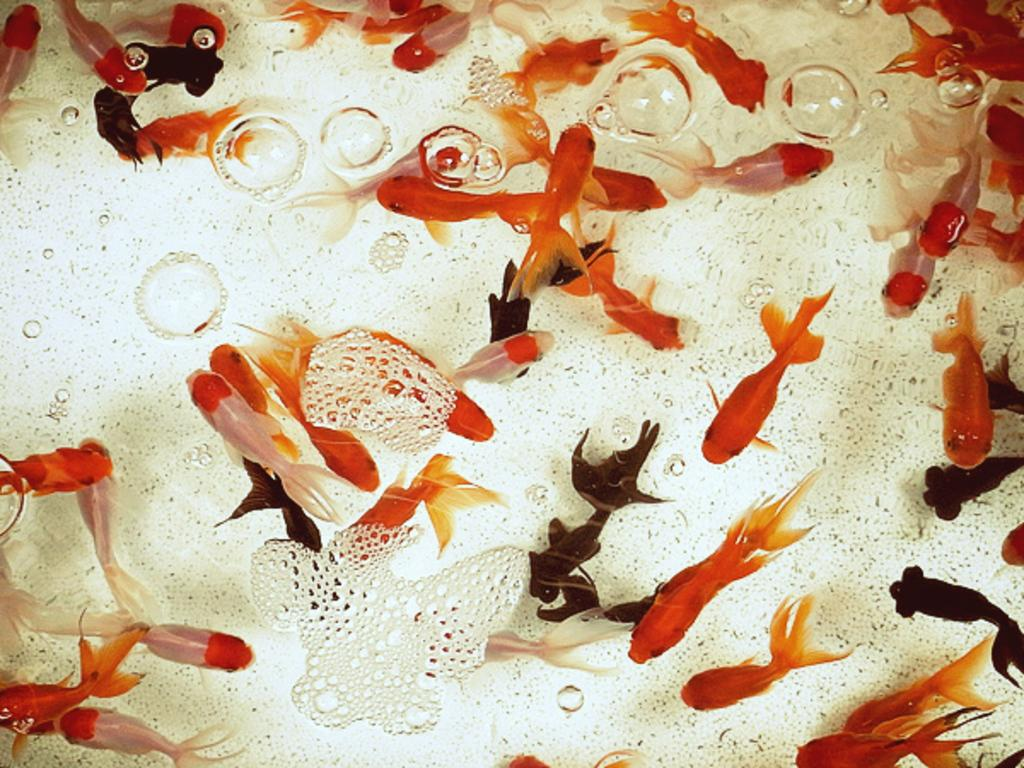What type of animals are in the image? There are fishes in the image. Where are the fishes located? The fishes are inside the water. What type of cable can be seen connecting the fishes in the image? There is no cable present in the image; the fishes are inside the water without any visible connections. 